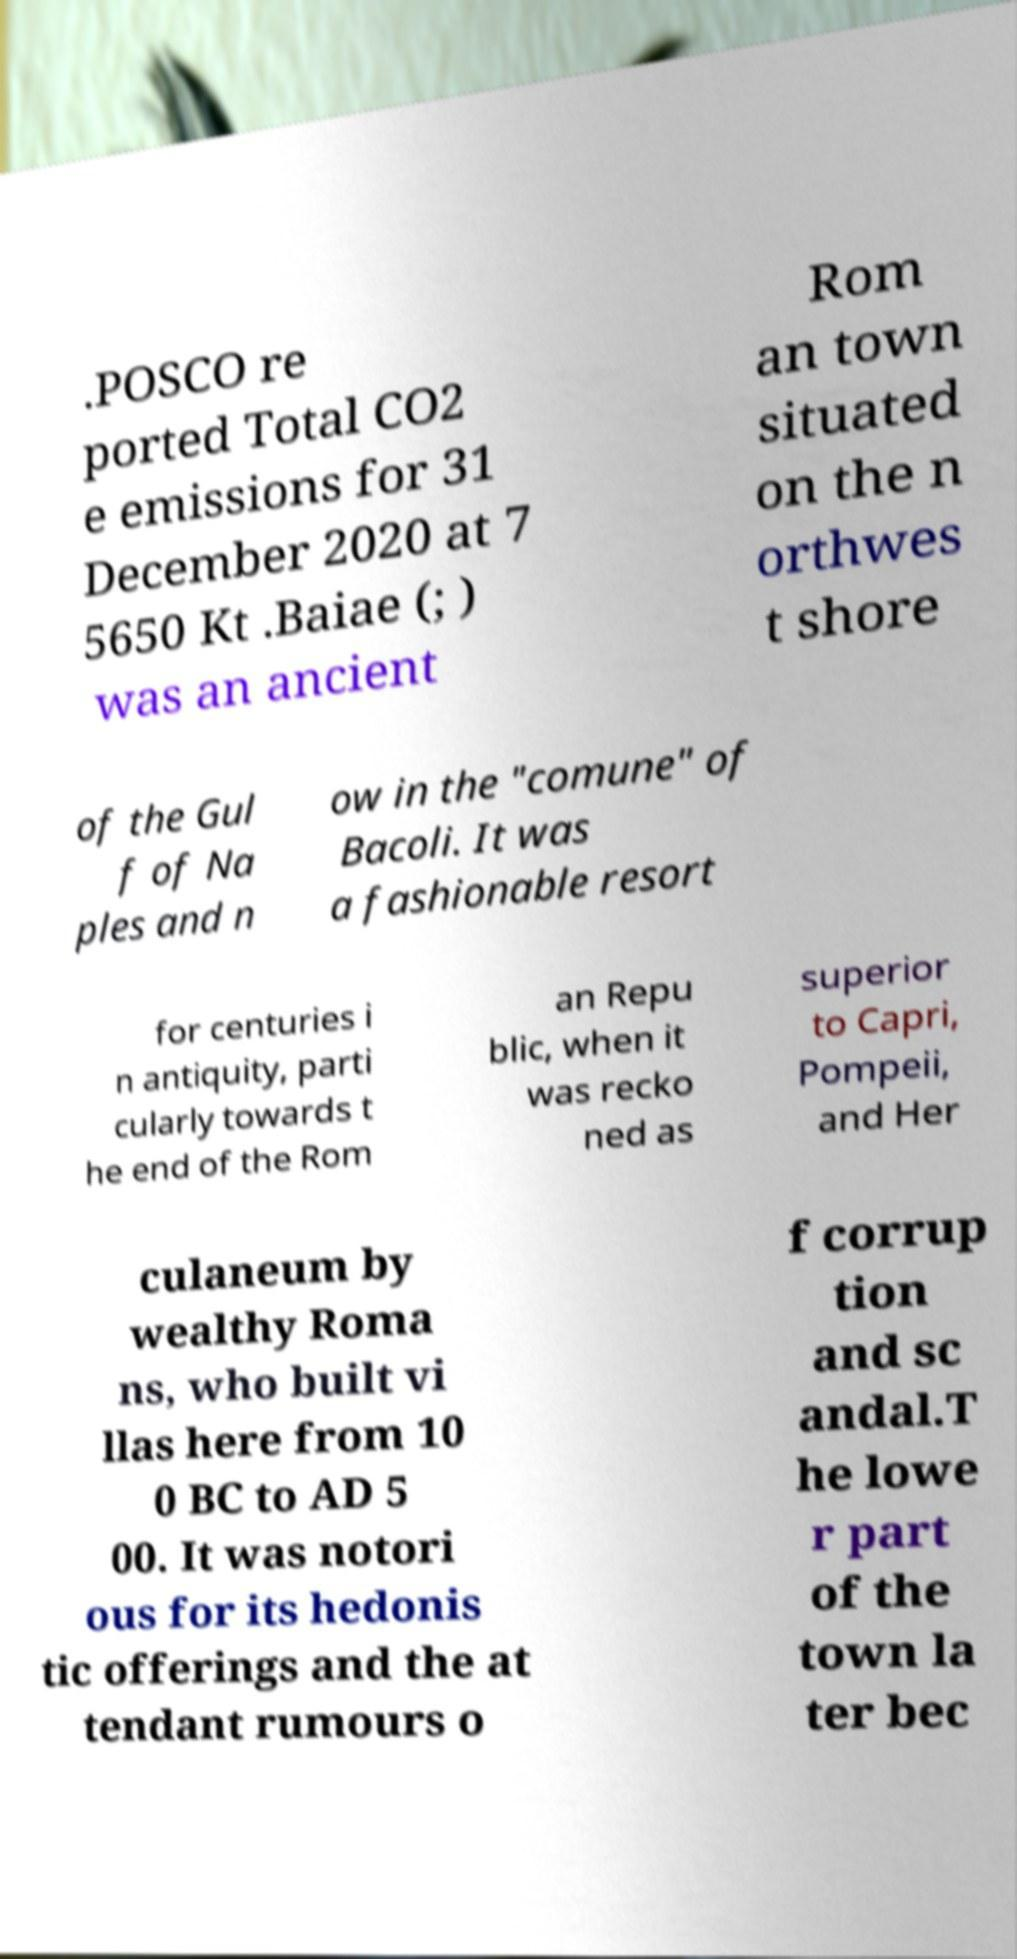There's text embedded in this image that I need extracted. Can you transcribe it verbatim? .POSCO re ported Total CO2 e emissions for 31 December 2020 at 7 5650 Kt .Baiae (; ) was an ancient Rom an town situated on the n orthwes t shore of the Gul f of Na ples and n ow in the "comune" of Bacoli. It was a fashionable resort for centuries i n antiquity, parti cularly towards t he end of the Rom an Repu blic, when it was recko ned as superior to Capri, Pompeii, and Her culaneum by wealthy Roma ns, who built vi llas here from 10 0 BC to AD 5 00. It was notori ous for its hedonis tic offerings and the at tendant rumours o f corrup tion and sc andal.T he lowe r part of the town la ter bec 